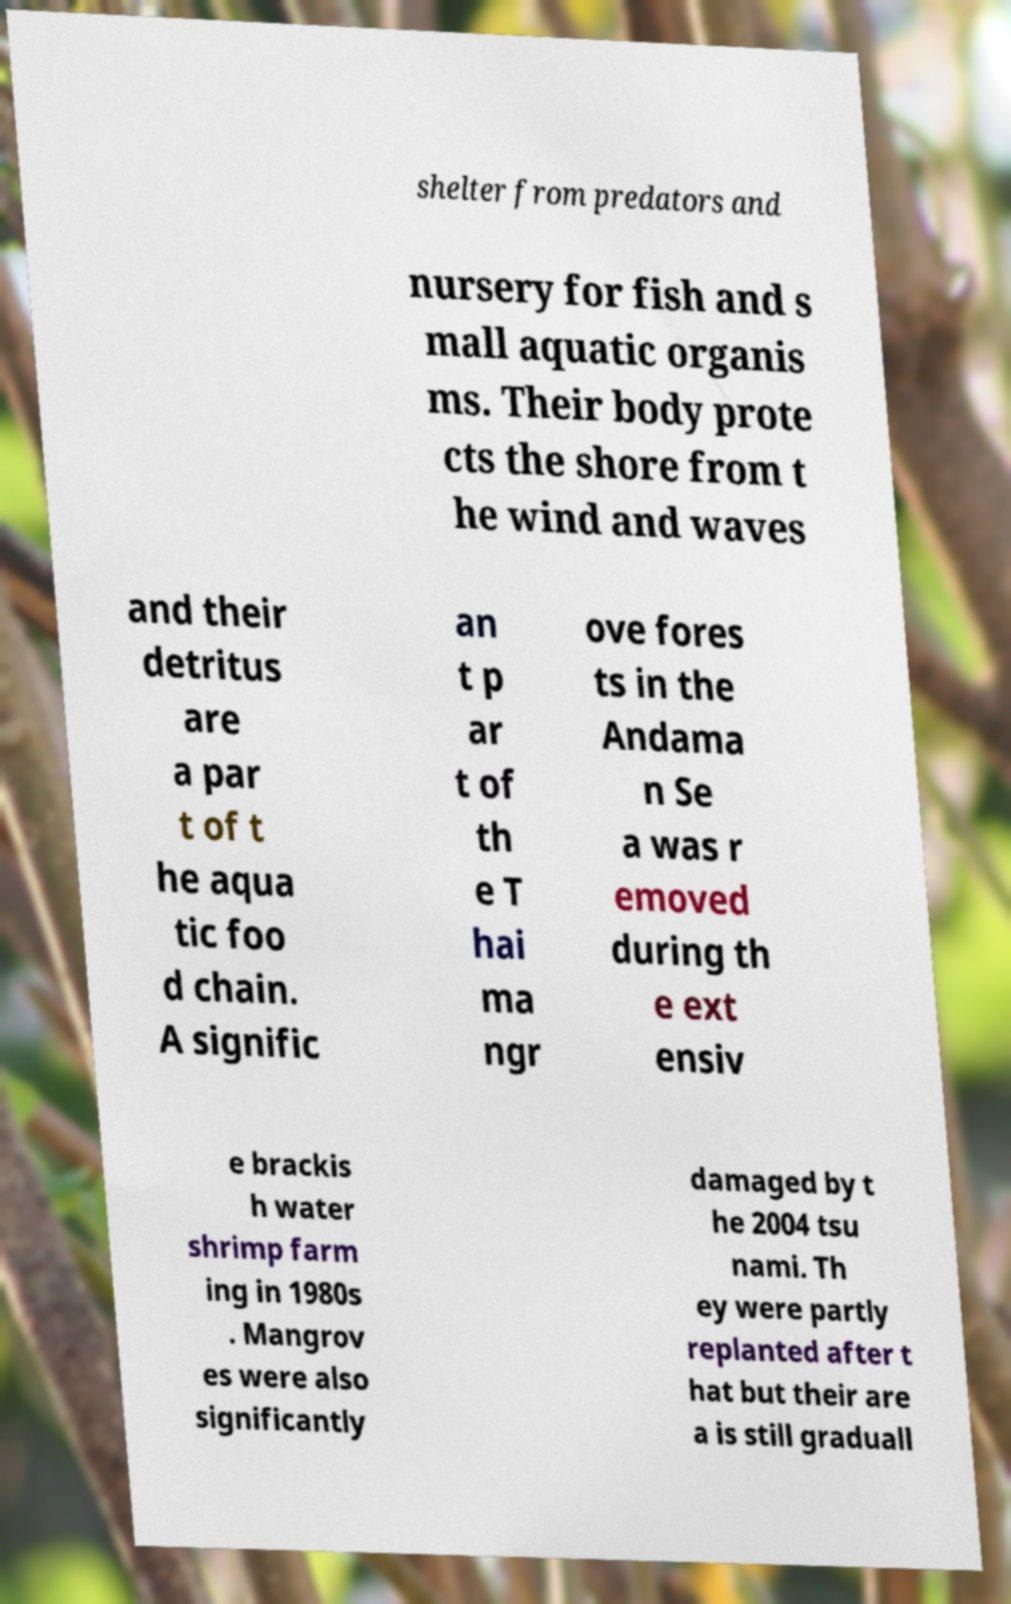Please identify and transcribe the text found in this image. shelter from predators and nursery for fish and s mall aquatic organis ms. Their body prote cts the shore from t he wind and waves and their detritus are a par t of t he aqua tic foo d chain. A signific an t p ar t of th e T hai ma ngr ove fores ts in the Andama n Se a was r emoved during th e ext ensiv e brackis h water shrimp farm ing in 1980s . Mangrov es were also significantly damaged by t he 2004 tsu nami. Th ey were partly replanted after t hat but their are a is still graduall 